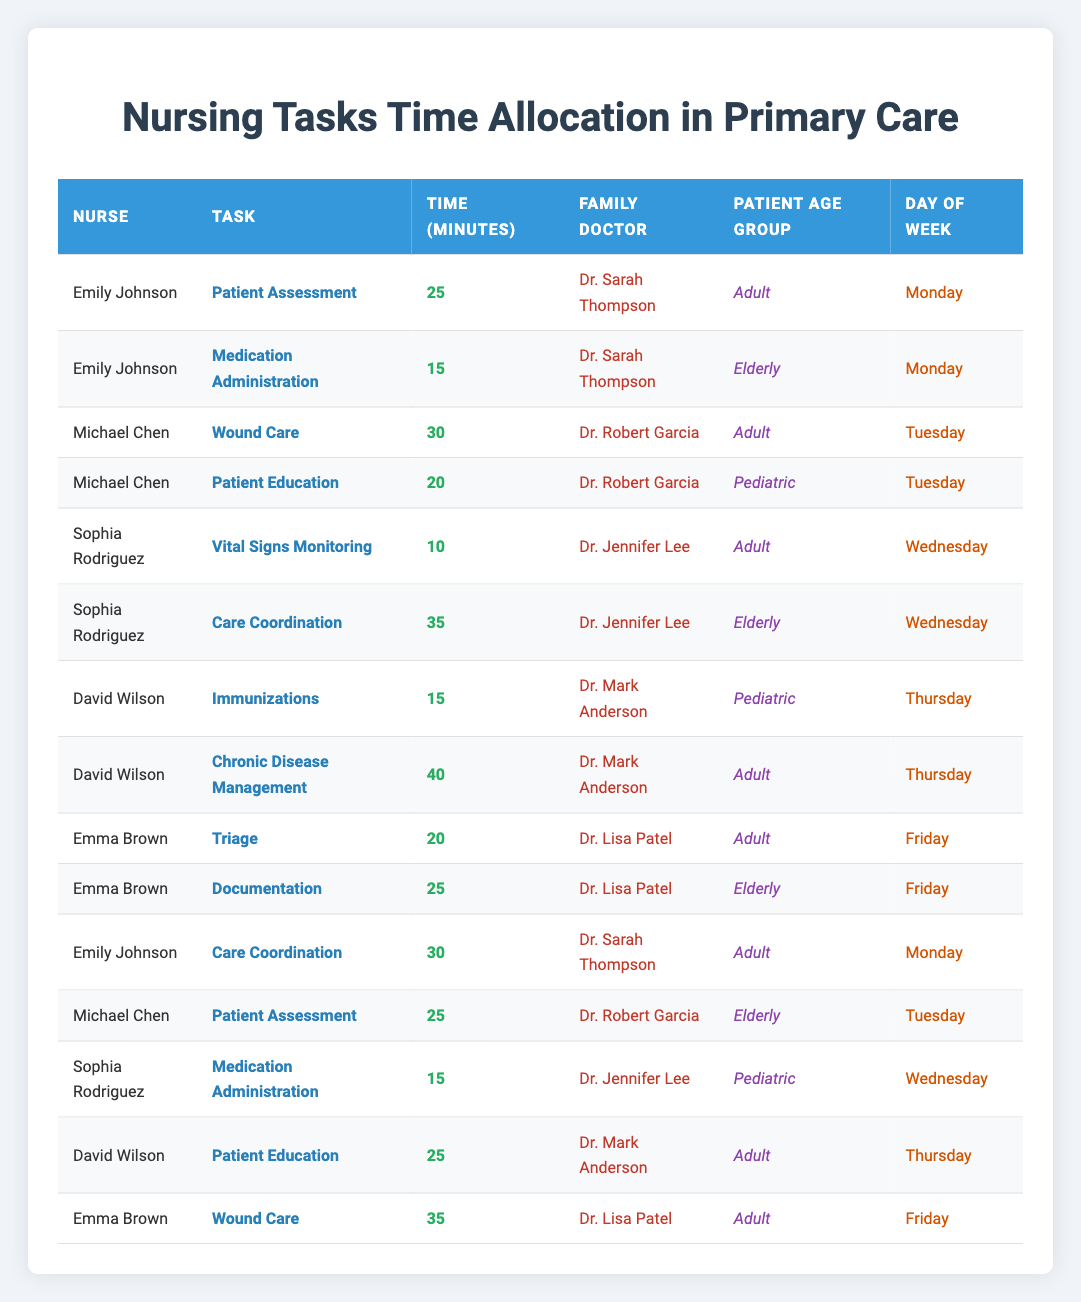What nursing task took the longest time for Michael Chen? The tasks Michael Chen performed were "Wound Care" for 30 minutes and "Patient Education" for 20 minutes. The longest time spent was on "Wound Care".
Answer: Wound Care How many minutes did Emily Johnson spend on tasks on Monday? Emily Johnson had two tasks on Monday: "Patient Assessment" took 25 minutes and "Care Coordination" took 30 minutes. Adding these gives 25 + 30 = 55 minutes in total.
Answer: 55 Did any nurse spend more than 40 minutes on a task in this table? The data shows that Emily Johnson, Michael Chen, Sophia Rodriguez, David Wilson, and Emma Brown, none of them spent more than 40 minutes on any single task (the maximum was 40 minutes for "Chronic Disease Management").
Answer: No What task did Sophia Rodriguez perform for the elderly patients? Sophia Rodriguez performed two tasks: "Vital Signs Monitoring" for Adults and "Care Coordination" for Elderly patients. Therefore, the specific task for the elderly is "Care Coordination".
Answer: Care Coordination Which family doctor had the highest total task time by nurses? Evaluating each doctor: Dr. Sarah Thompson had 55 minutes, Dr. Robert Garcia had 75 minutes (30 + 20 + 25), Dr. Jennifer Lee had 25 minutes (10 + 15), Dr. Mark Anderson had 70 minutes (15 + 40 + 25), and Dr. Lisa Patel had 60 minutes (20 + 25 + 35). Thus, Dr. Robert Garcia had the highest total, with 75 minutes.
Answer: Dr. Robert Garcia Which day of the week saw the most task allocations for David Wilson? David Wilson performed two tasks on Thursday: "Immunizations" and "Chronic Disease Management," which totals to two tasks, while on other days he had no other entries. Therefore, Thursday is the day with the most task allocation.
Answer: Thursday What percentage of Sophia Rodriguez's tasks were related to pediatric care? Sophia Rodriguez completed two tasks, and one of them ("Medication Administration") was for pediatric patients. The percentage calculation is (1/2) * 100 = 50%.
Answer: 50% Which nurse and day combination had the highest average minutes spent per task? To find this, we calculate the average minutes per task for each nurse across all days. Emily Johnson, Michael Chen, and David Wilson had totals near or above average with significant single task times, but Michael Chen's Wound Care of 30 gives insight to consider. Overall, it is more complex requiring thorough evaluation of the average across all columns. Thus, the exact combination is clearer after a detailed calculation based on total task time.
Answer: Michael Chen on Tuesday On which day did Emma Brown handle both triage and documentation and how many minutes in total? Emma Brown performed "Triage" on Friday for 20 minutes and "Documentation" also on Friday for 25 minutes, so the total for both tasks is 20 + 25 = 45 minutes.
Answer: Friday, 45 